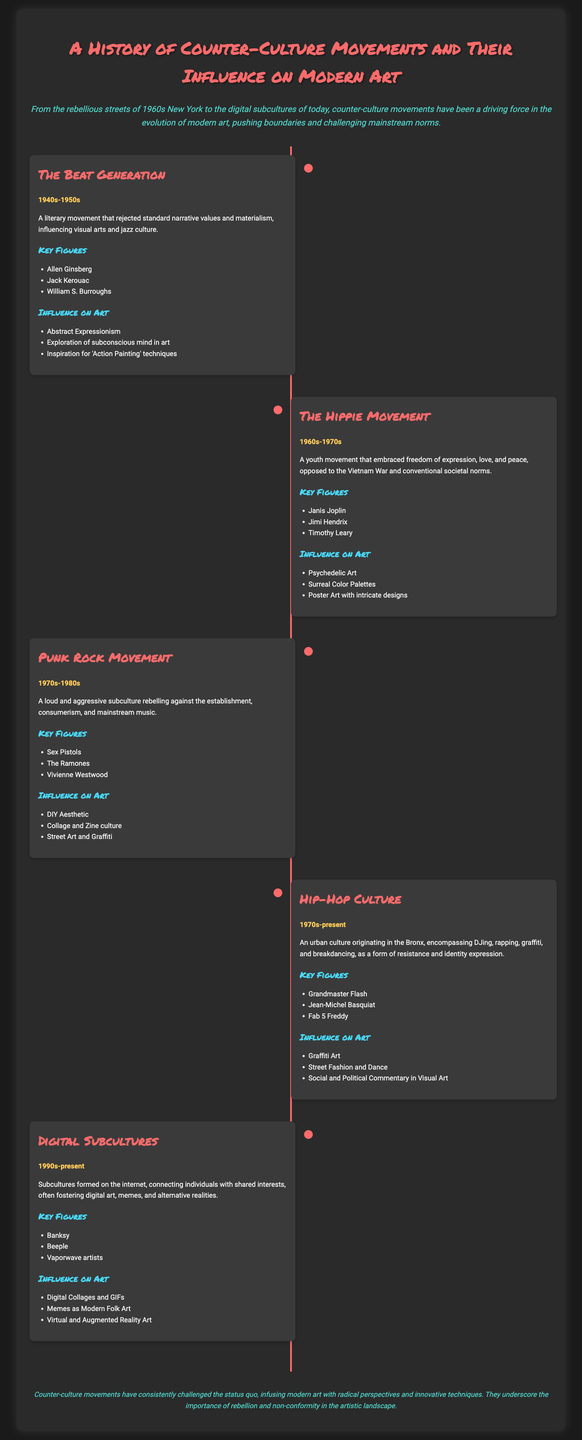What literary movement influenced visual arts and jazz culture in the 1940s-1950s? The Beat Generation was a literary movement that rejected standard narrative values and materialism, influencing visual arts and jazz culture.
Answer: The Beat Generation Who is a key figure associated with the Hippie Movement? The document lists Janis Joplin as a key figure of the Hippie Movement, which embraced freedom of expression.
Answer: Janis Joplin What was a significant artistic influence of the Punk Rock Movement? The Punk Rock Movement had a significant influence on the DIY aesthetic in art, reflecting its rebellious spirit.
Answer: DIY Aesthetic In what decade did Hip-Hop Culture begin? The document states that Hip-Hop Culture originated in the 1970s.
Answer: 1970s What type of art did Digital Subcultures foster? The document indicates that Digital Subcultures fostered digital art, memes, and alternative realities through the internet.
Answer: Digital art Which painting technique was inspired by the Beat Generation? 'Action Painting' techniques were inspired by the Beat Generation's exploration of the subconscious mind in art.
Answer: Action Painting What is a notable characteristic of the psychedelic art influenced by the Hippie Movement? The Hippie Movement's influence on art is characterized by surreal color palettes that evoke emotions and experiences.
Answer: Surreal Color Palettes What are memes considered in the context of Digital Subcultures? In the context of Digital Subcultures, memes are considered modern folk art that reflects cultural narratives.
Answer: Modern Folk Art 